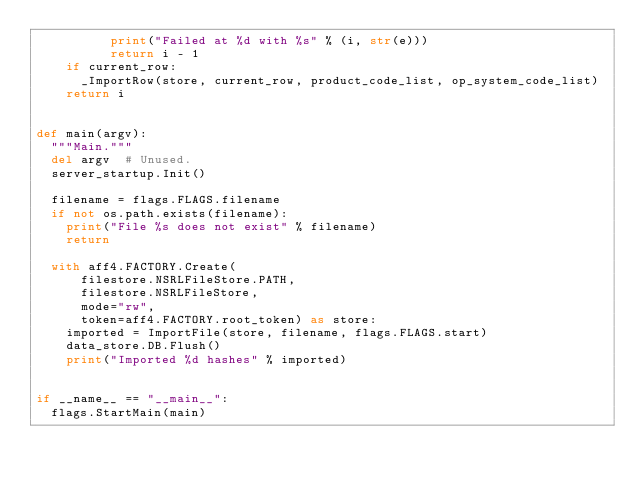<code> <loc_0><loc_0><loc_500><loc_500><_Python_>          print("Failed at %d with %s" % (i, str(e)))
          return i - 1
    if current_row:
      _ImportRow(store, current_row, product_code_list, op_system_code_list)
    return i


def main(argv):
  """Main."""
  del argv  # Unused.
  server_startup.Init()

  filename = flags.FLAGS.filename
  if not os.path.exists(filename):
    print("File %s does not exist" % filename)
    return

  with aff4.FACTORY.Create(
      filestore.NSRLFileStore.PATH,
      filestore.NSRLFileStore,
      mode="rw",
      token=aff4.FACTORY.root_token) as store:
    imported = ImportFile(store, filename, flags.FLAGS.start)
    data_store.DB.Flush()
    print("Imported %d hashes" % imported)


if __name__ == "__main__":
  flags.StartMain(main)
</code> 